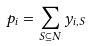Convert formula to latex. <formula><loc_0><loc_0><loc_500><loc_500>p _ { i } = \sum _ { S \subseteq N } y _ { i , S }</formula> 